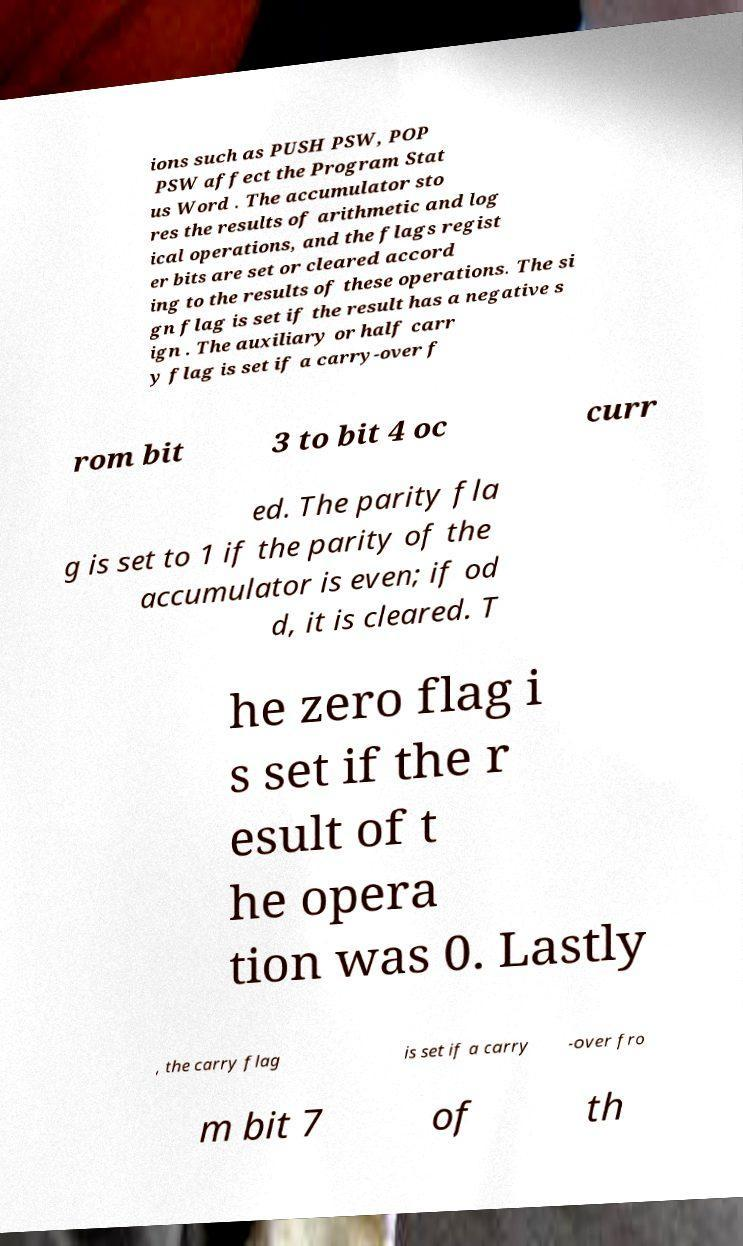For documentation purposes, I need the text within this image transcribed. Could you provide that? ions such as PUSH PSW, POP PSW affect the Program Stat us Word . The accumulator sto res the results of arithmetic and log ical operations, and the flags regist er bits are set or cleared accord ing to the results of these operations. The si gn flag is set if the result has a negative s ign . The auxiliary or half carr y flag is set if a carry-over f rom bit 3 to bit 4 oc curr ed. The parity fla g is set to 1 if the parity of the accumulator is even; if od d, it is cleared. T he zero flag i s set if the r esult of t he opera tion was 0. Lastly , the carry flag is set if a carry -over fro m bit 7 of th 